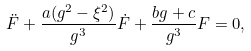Convert formula to latex. <formula><loc_0><loc_0><loc_500><loc_500>\ddot { F } + \frac { a ( g ^ { 2 } - \xi ^ { 2 } ) } { g ^ { 3 } } \dot { F } + \frac { b g + c } { g ^ { 3 } } F = 0 ,</formula> 